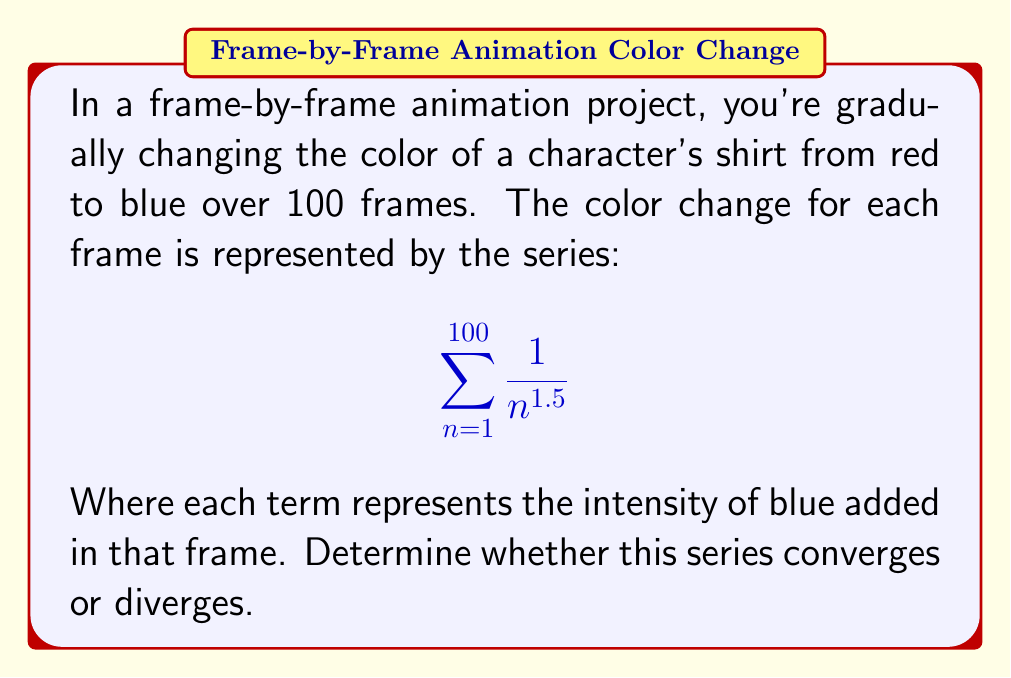Solve this math problem. To determine the convergence of this series, we can use the p-series test:

1) The general form of a p-series is:
   $$\sum_{n=1}^{\infty} \frac{1}{n^p}$$

2) In our case, $p = 1.5$

3) The p-series test states:
   - If $p > 1$, the series converges
   - If $p \leq 1$, the series diverges

4) Since $p = 1.5 > 1$, the series converges.

5) However, our series is finite (n goes from 1 to 100), and any finite sum of terms will always converge.

6) Therefore, our series converges for two reasons:
   a) It's a convergent p-series (p > 1)
   b) It's a finite series

Note: In the context of animation, this convergence means the color change is well-defined and will reach a specific final blue shade after 100 frames.
Answer: Converges 